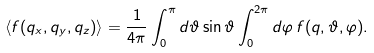<formula> <loc_0><loc_0><loc_500><loc_500>\langle f ( q _ { x } , q _ { y } , q _ { z } ) \rangle = \frac { 1 } { 4 \pi } \int _ { 0 } ^ { \pi } d \vartheta \sin \vartheta \int _ { 0 } ^ { 2 \pi } d \varphi \, f ( q , \vartheta , \varphi ) .</formula> 